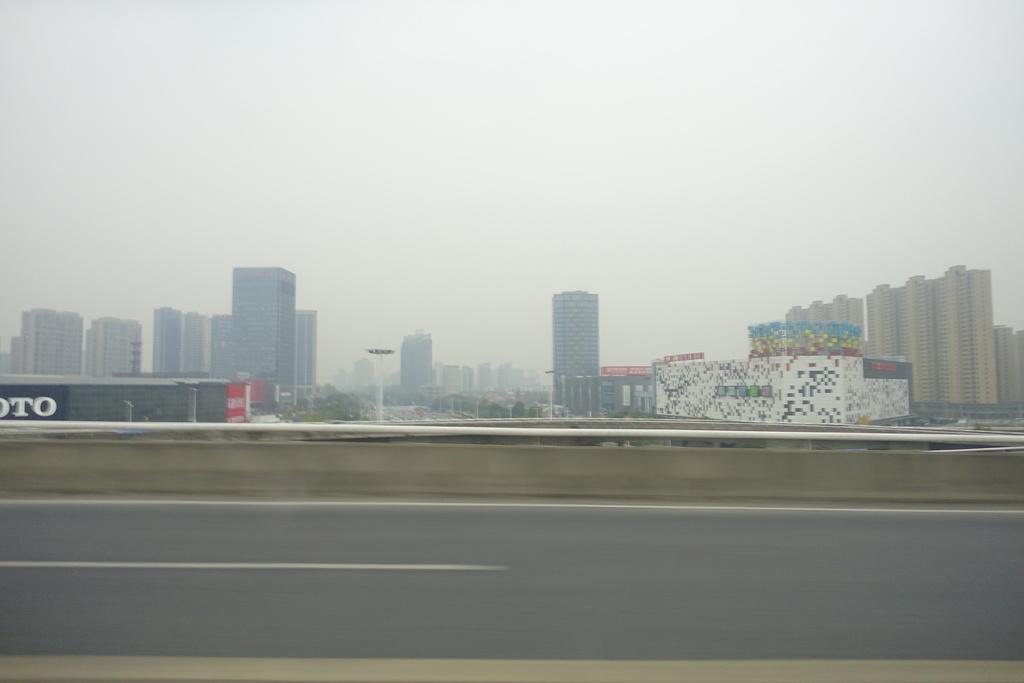Could you give a brief overview of what you see in this image? In this image, we can see a road. There are some buildings in the middle of the image. In the background of the image, there is a sky. 